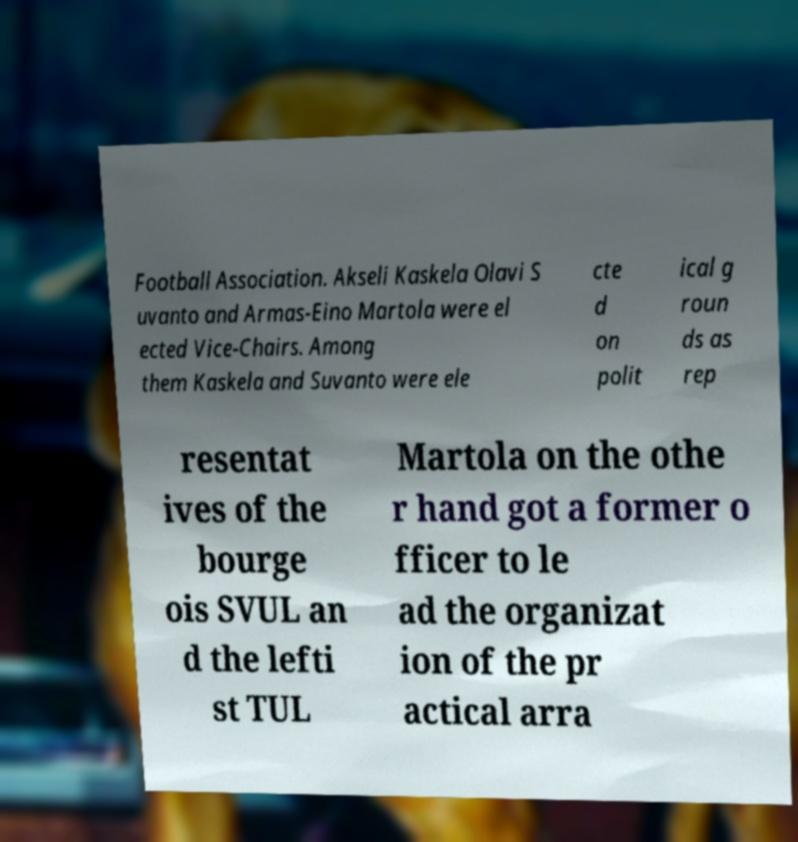For documentation purposes, I need the text within this image transcribed. Could you provide that? Football Association. Akseli Kaskela Olavi S uvanto and Armas-Eino Martola were el ected Vice-Chairs. Among them Kaskela and Suvanto were ele cte d on polit ical g roun ds as rep resentat ives of the bourge ois SVUL an d the lefti st TUL Martola on the othe r hand got a former o fficer to le ad the organizat ion of the pr actical arra 